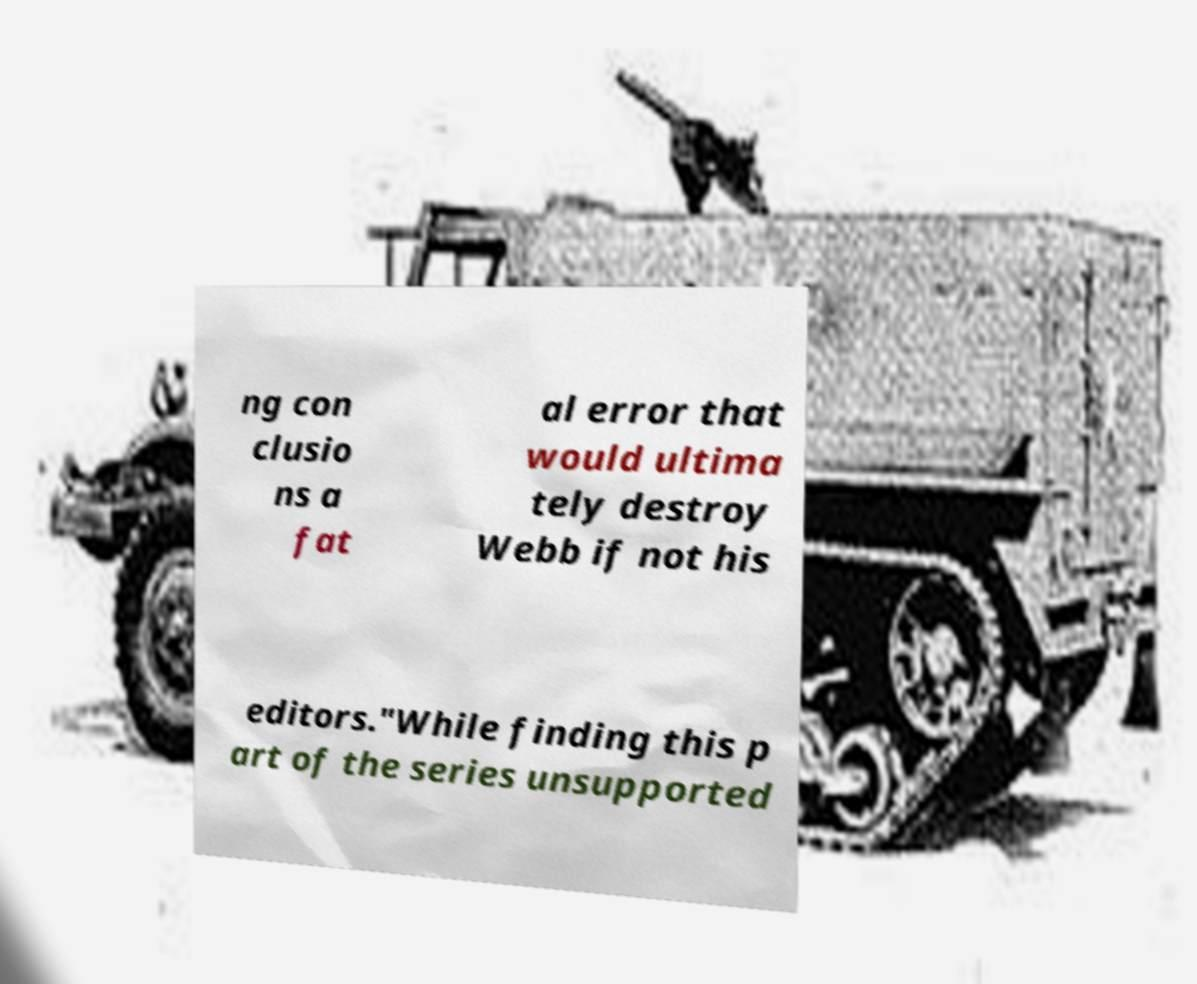I need the written content from this picture converted into text. Can you do that? ng con clusio ns a fat al error that would ultima tely destroy Webb if not his editors."While finding this p art of the series unsupported 